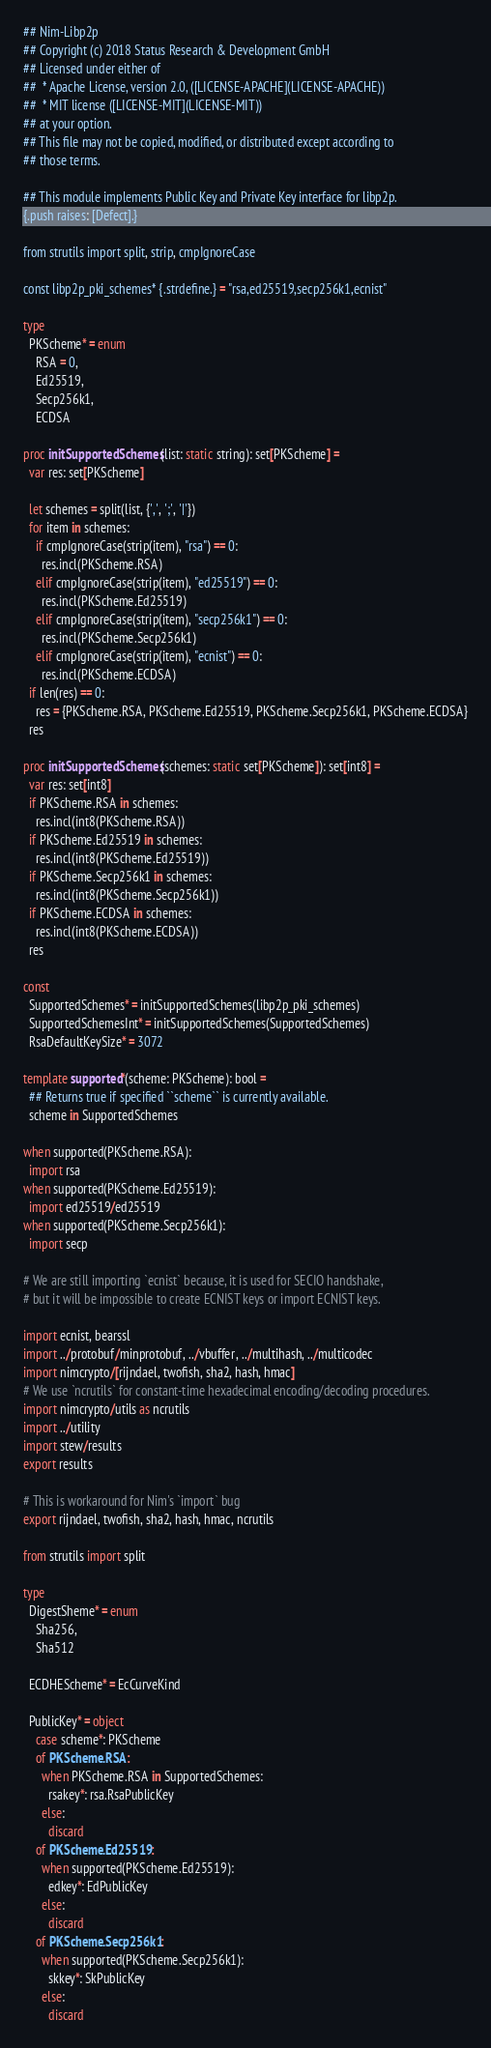Convert code to text. <code><loc_0><loc_0><loc_500><loc_500><_Nim_>## Nim-Libp2p
## Copyright (c) 2018 Status Research & Development GmbH
## Licensed under either of
##  * Apache License, version 2.0, ([LICENSE-APACHE](LICENSE-APACHE))
##  * MIT license ([LICENSE-MIT](LICENSE-MIT))
## at your option.
## This file may not be copied, modified, or distributed except according to
## those terms.

## This module implements Public Key and Private Key interface for libp2p.
{.push raises: [Defect].}

from strutils import split, strip, cmpIgnoreCase

const libp2p_pki_schemes* {.strdefine.} = "rsa,ed25519,secp256k1,ecnist"

type
  PKScheme* = enum
    RSA = 0,
    Ed25519,
    Secp256k1,
    ECDSA

proc initSupportedSchemes(list: static string): set[PKScheme] =
  var res: set[PKScheme]

  let schemes = split(list, {',', ';', '|'})
  for item in schemes:
    if cmpIgnoreCase(strip(item), "rsa") == 0:
      res.incl(PKScheme.RSA)
    elif cmpIgnoreCase(strip(item), "ed25519") == 0:
      res.incl(PKScheme.Ed25519)
    elif cmpIgnoreCase(strip(item), "secp256k1") == 0:
      res.incl(PKScheme.Secp256k1)
    elif cmpIgnoreCase(strip(item), "ecnist") == 0:
      res.incl(PKScheme.ECDSA)
  if len(res) == 0:
    res = {PKScheme.RSA, PKScheme.Ed25519, PKScheme.Secp256k1, PKScheme.ECDSA}
  res

proc initSupportedSchemes(schemes: static set[PKScheme]): set[int8] =
  var res: set[int8]
  if PKScheme.RSA in schemes:
    res.incl(int8(PKScheme.RSA))
  if PKScheme.Ed25519 in schemes:
    res.incl(int8(PKScheme.Ed25519))
  if PKScheme.Secp256k1 in schemes:
    res.incl(int8(PKScheme.Secp256k1))
  if PKScheme.ECDSA in schemes:
    res.incl(int8(PKScheme.ECDSA))
  res

const
  SupportedSchemes* = initSupportedSchemes(libp2p_pki_schemes)
  SupportedSchemesInt* = initSupportedSchemes(SupportedSchemes)
  RsaDefaultKeySize* = 3072

template supported*(scheme: PKScheme): bool =
  ## Returns true if specified ``scheme`` is currently available.
  scheme in SupportedSchemes

when supported(PKScheme.RSA):
  import rsa
when supported(PKScheme.Ed25519):
  import ed25519/ed25519
when supported(PKScheme.Secp256k1):
  import secp

# We are still importing `ecnist` because, it is used for SECIO handshake,
# but it will be impossible to create ECNIST keys or import ECNIST keys.

import ecnist, bearssl
import ../protobuf/minprotobuf, ../vbuffer, ../multihash, ../multicodec
import nimcrypto/[rijndael, twofish, sha2, hash, hmac]
# We use `ncrutils` for constant-time hexadecimal encoding/decoding procedures.
import nimcrypto/utils as ncrutils
import ../utility
import stew/results
export results

# This is workaround for Nim's `import` bug
export rijndael, twofish, sha2, hash, hmac, ncrutils

from strutils import split

type
  DigestSheme* = enum
    Sha256,
    Sha512

  ECDHEScheme* = EcCurveKind

  PublicKey* = object
    case scheme*: PKScheme
    of PKScheme.RSA:
      when PKScheme.RSA in SupportedSchemes:
        rsakey*: rsa.RsaPublicKey
      else:
        discard
    of PKScheme.Ed25519:
      when supported(PKScheme.Ed25519):
        edkey*: EdPublicKey
      else:
        discard
    of PKScheme.Secp256k1:
      when supported(PKScheme.Secp256k1):
        skkey*: SkPublicKey
      else:
        discard</code> 